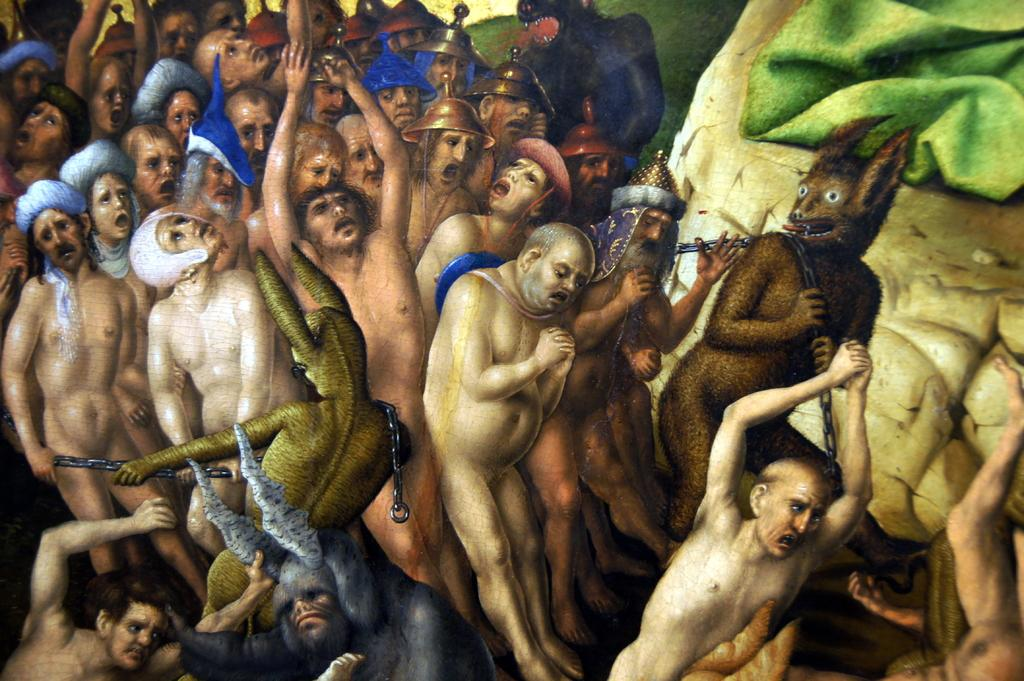Who or what can be seen in the image? There are people and animals in the image. Can you describe the people in the image? Unfortunately, the provided facts do not give any specific details about the people in the image. What kind of animals are present in the image? The provided facts do not specify the type of animals in the image. What force is being applied to the animals in the image? There is no force being applied to the animals in the image, as the provided facts do not mention any interaction between the people and animals. 